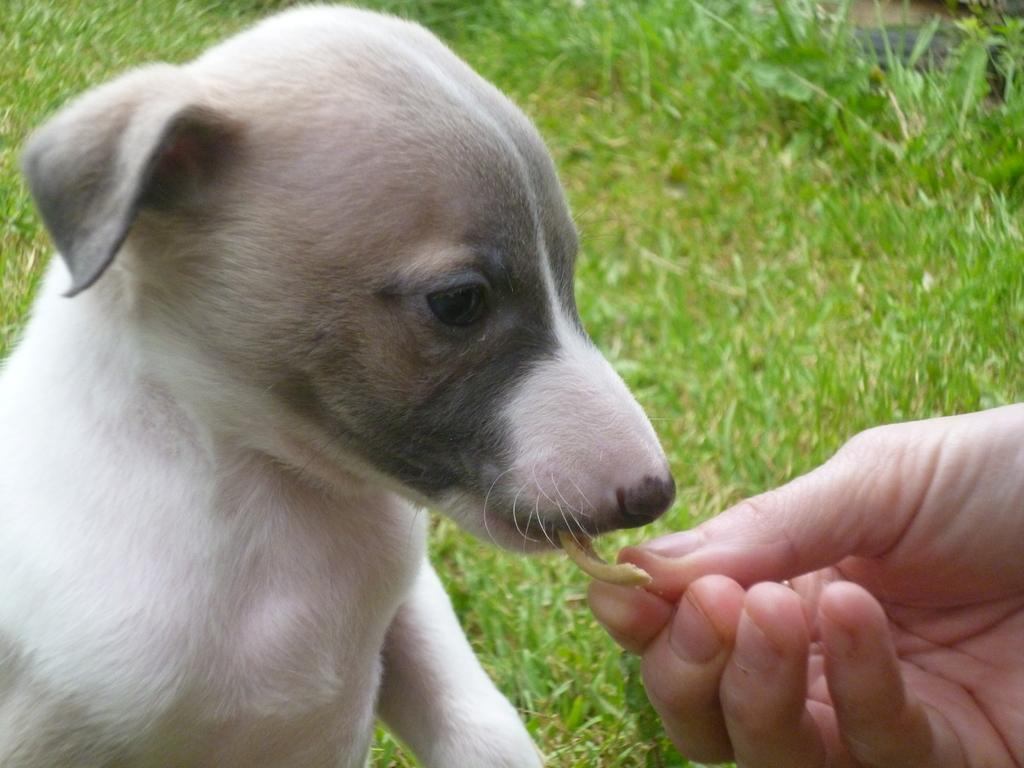What can be seen on the right side of the image? There is a person's hand on the right side of the image. What is the person's hand doing in the image? The hand is feeding a food item to a dog. What type of surface is visible in the background of the image? There is grass on the ground in the background of the image. What type of vessel is being used by the person to hear the dog's thoughts in the image? There is no vessel or indication of hearing the dog's thoughts in the image. 